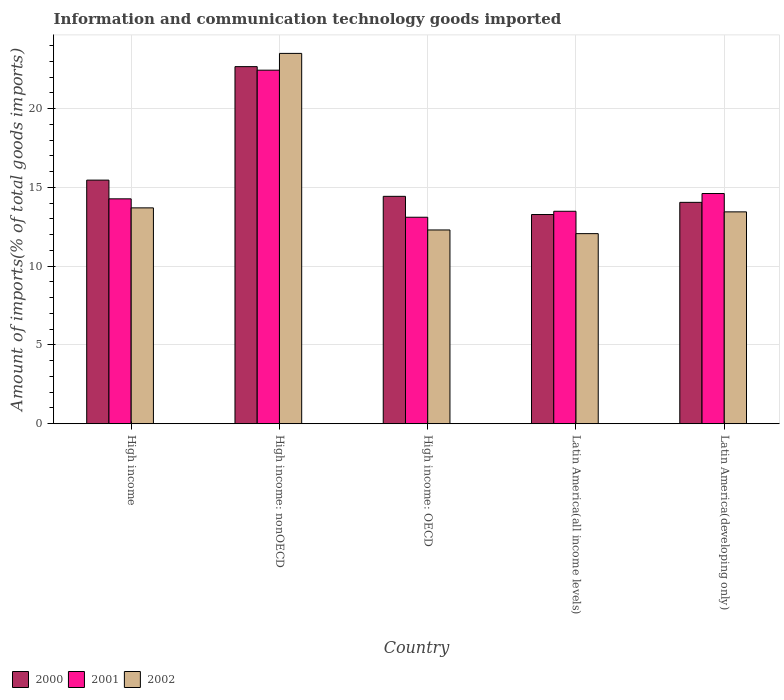How many different coloured bars are there?
Provide a succinct answer. 3. Are the number of bars per tick equal to the number of legend labels?
Make the answer very short. Yes. Are the number of bars on each tick of the X-axis equal?
Provide a short and direct response. Yes. How many bars are there on the 2nd tick from the left?
Provide a short and direct response. 3. What is the label of the 1st group of bars from the left?
Offer a terse response. High income. In how many cases, is the number of bars for a given country not equal to the number of legend labels?
Your answer should be compact. 0. What is the amount of goods imported in 2001 in Latin America(all income levels)?
Offer a very short reply. 13.48. Across all countries, what is the maximum amount of goods imported in 2000?
Offer a very short reply. 22.66. Across all countries, what is the minimum amount of goods imported in 2002?
Provide a short and direct response. 12.06. In which country was the amount of goods imported in 2001 maximum?
Provide a succinct answer. High income: nonOECD. In which country was the amount of goods imported in 2002 minimum?
Offer a very short reply. Latin America(all income levels). What is the total amount of goods imported in 2001 in the graph?
Offer a very short reply. 77.89. What is the difference between the amount of goods imported in 2001 in Latin America(all income levels) and that in Latin America(developing only)?
Your answer should be very brief. -1.13. What is the difference between the amount of goods imported in 2002 in Latin America(developing only) and the amount of goods imported in 2000 in High income: OECD?
Make the answer very short. -0.99. What is the average amount of goods imported in 2002 per country?
Your answer should be very brief. 15. What is the difference between the amount of goods imported of/in 2000 and amount of goods imported of/in 2001 in High income?
Give a very brief answer. 1.19. In how many countries, is the amount of goods imported in 2002 greater than 10 %?
Offer a terse response. 5. What is the ratio of the amount of goods imported in 2000 in High income to that in High income: nonOECD?
Offer a very short reply. 0.68. Is the amount of goods imported in 2001 in High income less than that in High income: nonOECD?
Your response must be concise. Yes. What is the difference between the highest and the second highest amount of goods imported in 2001?
Offer a very short reply. -8.16. What is the difference between the highest and the lowest amount of goods imported in 2000?
Your answer should be very brief. 9.38. In how many countries, is the amount of goods imported in 2000 greater than the average amount of goods imported in 2000 taken over all countries?
Make the answer very short. 1. Are all the bars in the graph horizontal?
Offer a terse response. No. How many countries are there in the graph?
Provide a short and direct response. 5. Are the values on the major ticks of Y-axis written in scientific E-notation?
Keep it short and to the point. No. Does the graph contain any zero values?
Give a very brief answer. No. How are the legend labels stacked?
Provide a succinct answer. Horizontal. What is the title of the graph?
Your answer should be compact. Information and communication technology goods imported. What is the label or title of the Y-axis?
Offer a terse response. Amount of imports(% of total goods imports). What is the Amount of imports(% of total goods imports) of 2000 in High income?
Offer a terse response. 15.46. What is the Amount of imports(% of total goods imports) of 2001 in High income?
Offer a very short reply. 14.27. What is the Amount of imports(% of total goods imports) in 2002 in High income?
Offer a terse response. 13.7. What is the Amount of imports(% of total goods imports) in 2000 in High income: nonOECD?
Your answer should be compact. 22.66. What is the Amount of imports(% of total goods imports) in 2001 in High income: nonOECD?
Offer a very short reply. 22.43. What is the Amount of imports(% of total goods imports) in 2002 in High income: nonOECD?
Offer a very short reply. 23.5. What is the Amount of imports(% of total goods imports) in 2000 in High income: OECD?
Keep it short and to the point. 14.43. What is the Amount of imports(% of total goods imports) of 2001 in High income: OECD?
Keep it short and to the point. 13.1. What is the Amount of imports(% of total goods imports) of 2002 in High income: OECD?
Provide a succinct answer. 12.3. What is the Amount of imports(% of total goods imports) in 2000 in Latin America(all income levels)?
Make the answer very short. 13.27. What is the Amount of imports(% of total goods imports) of 2001 in Latin America(all income levels)?
Ensure brevity in your answer.  13.48. What is the Amount of imports(% of total goods imports) of 2002 in Latin America(all income levels)?
Offer a very short reply. 12.06. What is the Amount of imports(% of total goods imports) of 2000 in Latin America(developing only)?
Ensure brevity in your answer.  14.05. What is the Amount of imports(% of total goods imports) in 2001 in Latin America(developing only)?
Make the answer very short. 14.61. What is the Amount of imports(% of total goods imports) of 2002 in Latin America(developing only)?
Offer a very short reply. 13.44. Across all countries, what is the maximum Amount of imports(% of total goods imports) of 2000?
Provide a succinct answer. 22.66. Across all countries, what is the maximum Amount of imports(% of total goods imports) in 2001?
Your response must be concise. 22.43. Across all countries, what is the maximum Amount of imports(% of total goods imports) of 2002?
Offer a very short reply. 23.5. Across all countries, what is the minimum Amount of imports(% of total goods imports) of 2000?
Your answer should be very brief. 13.27. Across all countries, what is the minimum Amount of imports(% of total goods imports) of 2001?
Your answer should be very brief. 13.1. Across all countries, what is the minimum Amount of imports(% of total goods imports) in 2002?
Make the answer very short. 12.06. What is the total Amount of imports(% of total goods imports) in 2000 in the graph?
Ensure brevity in your answer.  79.87. What is the total Amount of imports(% of total goods imports) in 2001 in the graph?
Provide a short and direct response. 77.89. What is the total Amount of imports(% of total goods imports) of 2002 in the graph?
Your answer should be very brief. 75. What is the difference between the Amount of imports(% of total goods imports) in 2000 in High income and that in High income: nonOECD?
Ensure brevity in your answer.  -7.2. What is the difference between the Amount of imports(% of total goods imports) of 2001 in High income and that in High income: nonOECD?
Offer a very short reply. -8.16. What is the difference between the Amount of imports(% of total goods imports) in 2002 in High income and that in High income: nonOECD?
Give a very brief answer. -9.8. What is the difference between the Amount of imports(% of total goods imports) in 2000 in High income and that in High income: OECD?
Provide a short and direct response. 1.03. What is the difference between the Amount of imports(% of total goods imports) of 2001 in High income and that in High income: OECD?
Offer a terse response. 1.17. What is the difference between the Amount of imports(% of total goods imports) of 2002 in High income and that in High income: OECD?
Provide a short and direct response. 1.4. What is the difference between the Amount of imports(% of total goods imports) in 2000 in High income and that in Latin America(all income levels)?
Keep it short and to the point. 2.18. What is the difference between the Amount of imports(% of total goods imports) of 2001 in High income and that in Latin America(all income levels)?
Ensure brevity in your answer.  0.79. What is the difference between the Amount of imports(% of total goods imports) in 2002 in High income and that in Latin America(all income levels)?
Ensure brevity in your answer.  1.63. What is the difference between the Amount of imports(% of total goods imports) of 2000 in High income and that in Latin America(developing only)?
Provide a short and direct response. 1.41. What is the difference between the Amount of imports(% of total goods imports) of 2001 in High income and that in Latin America(developing only)?
Make the answer very short. -0.34. What is the difference between the Amount of imports(% of total goods imports) in 2002 in High income and that in Latin America(developing only)?
Your answer should be very brief. 0.25. What is the difference between the Amount of imports(% of total goods imports) in 2000 in High income: nonOECD and that in High income: OECD?
Provide a succinct answer. 8.23. What is the difference between the Amount of imports(% of total goods imports) in 2001 in High income: nonOECD and that in High income: OECD?
Give a very brief answer. 9.33. What is the difference between the Amount of imports(% of total goods imports) in 2002 in High income: nonOECD and that in High income: OECD?
Your answer should be very brief. 11.2. What is the difference between the Amount of imports(% of total goods imports) of 2000 in High income: nonOECD and that in Latin America(all income levels)?
Your answer should be very brief. 9.38. What is the difference between the Amount of imports(% of total goods imports) in 2001 in High income: nonOECD and that in Latin America(all income levels)?
Your response must be concise. 8.95. What is the difference between the Amount of imports(% of total goods imports) of 2002 in High income: nonOECD and that in Latin America(all income levels)?
Your answer should be very brief. 11.44. What is the difference between the Amount of imports(% of total goods imports) of 2000 in High income: nonOECD and that in Latin America(developing only)?
Ensure brevity in your answer.  8.61. What is the difference between the Amount of imports(% of total goods imports) in 2001 in High income: nonOECD and that in Latin America(developing only)?
Your response must be concise. 7.83. What is the difference between the Amount of imports(% of total goods imports) of 2002 in High income: nonOECD and that in Latin America(developing only)?
Provide a succinct answer. 10.06. What is the difference between the Amount of imports(% of total goods imports) of 2000 in High income: OECD and that in Latin America(all income levels)?
Make the answer very short. 1.15. What is the difference between the Amount of imports(% of total goods imports) in 2001 in High income: OECD and that in Latin America(all income levels)?
Keep it short and to the point. -0.38. What is the difference between the Amount of imports(% of total goods imports) in 2002 in High income: OECD and that in Latin America(all income levels)?
Your answer should be very brief. 0.23. What is the difference between the Amount of imports(% of total goods imports) of 2000 in High income: OECD and that in Latin America(developing only)?
Offer a very short reply. 0.38. What is the difference between the Amount of imports(% of total goods imports) of 2001 in High income: OECD and that in Latin America(developing only)?
Ensure brevity in your answer.  -1.5. What is the difference between the Amount of imports(% of total goods imports) in 2002 in High income: OECD and that in Latin America(developing only)?
Provide a succinct answer. -1.15. What is the difference between the Amount of imports(% of total goods imports) in 2000 in Latin America(all income levels) and that in Latin America(developing only)?
Provide a succinct answer. -0.77. What is the difference between the Amount of imports(% of total goods imports) of 2001 in Latin America(all income levels) and that in Latin America(developing only)?
Provide a succinct answer. -1.13. What is the difference between the Amount of imports(% of total goods imports) of 2002 in Latin America(all income levels) and that in Latin America(developing only)?
Your answer should be very brief. -1.38. What is the difference between the Amount of imports(% of total goods imports) of 2000 in High income and the Amount of imports(% of total goods imports) of 2001 in High income: nonOECD?
Offer a very short reply. -6.97. What is the difference between the Amount of imports(% of total goods imports) in 2000 in High income and the Amount of imports(% of total goods imports) in 2002 in High income: nonOECD?
Offer a very short reply. -8.04. What is the difference between the Amount of imports(% of total goods imports) of 2001 in High income and the Amount of imports(% of total goods imports) of 2002 in High income: nonOECD?
Provide a short and direct response. -9.23. What is the difference between the Amount of imports(% of total goods imports) of 2000 in High income and the Amount of imports(% of total goods imports) of 2001 in High income: OECD?
Provide a succinct answer. 2.36. What is the difference between the Amount of imports(% of total goods imports) in 2000 in High income and the Amount of imports(% of total goods imports) in 2002 in High income: OECD?
Give a very brief answer. 3.16. What is the difference between the Amount of imports(% of total goods imports) in 2001 in High income and the Amount of imports(% of total goods imports) in 2002 in High income: OECD?
Offer a very short reply. 1.97. What is the difference between the Amount of imports(% of total goods imports) of 2000 in High income and the Amount of imports(% of total goods imports) of 2001 in Latin America(all income levels)?
Make the answer very short. 1.98. What is the difference between the Amount of imports(% of total goods imports) in 2000 in High income and the Amount of imports(% of total goods imports) in 2002 in Latin America(all income levels)?
Your response must be concise. 3.4. What is the difference between the Amount of imports(% of total goods imports) in 2001 in High income and the Amount of imports(% of total goods imports) in 2002 in Latin America(all income levels)?
Offer a very short reply. 2.21. What is the difference between the Amount of imports(% of total goods imports) in 2000 in High income and the Amount of imports(% of total goods imports) in 2001 in Latin America(developing only)?
Keep it short and to the point. 0.85. What is the difference between the Amount of imports(% of total goods imports) of 2000 in High income and the Amount of imports(% of total goods imports) of 2002 in Latin America(developing only)?
Make the answer very short. 2.02. What is the difference between the Amount of imports(% of total goods imports) in 2001 in High income and the Amount of imports(% of total goods imports) in 2002 in Latin America(developing only)?
Offer a very short reply. 0.83. What is the difference between the Amount of imports(% of total goods imports) in 2000 in High income: nonOECD and the Amount of imports(% of total goods imports) in 2001 in High income: OECD?
Your answer should be very brief. 9.56. What is the difference between the Amount of imports(% of total goods imports) in 2000 in High income: nonOECD and the Amount of imports(% of total goods imports) in 2002 in High income: OECD?
Your response must be concise. 10.36. What is the difference between the Amount of imports(% of total goods imports) in 2001 in High income: nonOECD and the Amount of imports(% of total goods imports) in 2002 in High income: OECD?
Offer a terse response. 10.14. What is the difference between the Amount of imports(% of total goods imports) of 2000 in High income: nonOECD and the Amount of imports(% of total goods imports) of 2001 in Latin America(all income levels)?
Make the answer very short. 9.18. What is the difference between the Amount of imports(% of total goods imports) in 2000 in High income: nonOECD and the Amount of imports(% of total goods imports) in 2002 in Latin America(all income levels)?
Ensure brevity in your answer.  10.6. What is the difference between the Amount of imports(% of total goods imports) of 2001 in High income: nonOECD and the Amount of imports(% of total goods imports) of 2002 in Latin America(all income levels)?
Your answer should be very brief. 10.37. What is the difference between the Amount of imports(% of total goods imports) of 2000 in High income: nonOECD and the Amount of imports(% of total goods imports) of 2001 in Latin America(developing only)?
Ensure brevity in your answer.  8.05. What is the difference between the Amount of imports(% of total goods imports) in 2000 in High income: nonOECD and the Amount of imports(% of total goods imports) in 2002 in Latin America(developing only)?
Offer a very short reply. 9.22. What is the difference between the Amount of imports(% of total goods imports) of 2001 in High income: nonOECD and the Amount of imports(% of total goods imports) of 2002 in Latin America(developing only)?
Ensure brevity in your answer.  8.99. What is the difference between the Amount of imports(% of total goods imports) of 2000 in High income: OECD and the Amount of imports(% of total goods imports) of 2001 in Latin America(all income levels)?
Make the answer very short. 0.95. What is the difference between the Amount of imports(% of total goods imports) in 2000 in High income: OECD and the Amount of imports(% of total goods imports) in 2002 in Latin America(all income levels)?
Make the answer very short. 2.37. What is the difference between the Amount of imports(% of total goods imports) in 2001 in High income: OECD and the Amount of imports(% of total goods imports) in 2002 in Latin America(all income levels)?
Your answer should be very brief. 1.04. What is the difference between the Amount of imports(% of total goods imports) of 2000 in High income: OECD and the Amount of imports(% of total goods imports) of 2001 in Latin America(developing only)?
Your answer should be compact. -0.18. What is the difference between the Amount of imports(% of total goods imports) in 2000 in High income: OECD and the Amount of imports(% of total goods imports) in 2002 in Latin America(developing only)?
Your answer should be compact. 0.99. What is the difference between the Amount of imports(% of total goods imports) of 2001 in High income: OECD and the Amount of imports(% of total goods imports) of 2002 in Latin America(developing only)?
Provide a succinct answer. -0.34. What is the difference between the Amount of imports(% of total goods imports) in 2000 in Latin America(all income levels) and the Amount of imports(% of total goods imports) in 2001 in Latin America(developing only)?
Ensure brevity in your answer.  -1.33. What is the difference between the Amount of imports(% of total goods imports) of 2000 in Latin America(all income levels) and the Amount of imports(% of total goods imports) of 2002 in Latin America(developing only)?
Provide a short and direct response. -0.17. What is the difference between the Amount of imports(% of total goods imports) of 2001 in Latin America(all income levels) and the Amount of imports(% of total goods imports) of 2002 in Latin America(developing only)?
Offer a terse response. 0.04. What is the average Amount of imports(% of total goods imports) in 2000 per country?
Provide a succinct answer. 15.97. What is the average Amount of imports(% of total goods imports) of 2001 per country?
Give a very brief answer. 15.58. What is the average Amount of imports(% of total goods imports) in 2002 per country?
Make the answer very short. 15. What is the difference between the Amount of imports(% of total goods imports) of 2000 and Amount of imports(% of total goods imports) of 2001 in High income?
Your response must be concise. 1.19. What is the difference between the Amount of imports(% of total goods imports) in 2000 and Amount of imports(% of total goods imports) in 2002 in High income?
Provide a short and direct response. 1.76. What is the difference between the Amount of imports(% of total goods imports) of 2001 and Amount of imports(% of total goods imports) of 2002 in High income?
Offer a terse response. 0.57. What is the difference between the Amount of imports(% of total goods imports) of 2000 and Amount of imports(% of total goods imports) of 2001 in High income: nonOECD?
Provide a succinct answer. 0.23. What is the difference between the Amount of imports(% of total goods imports) of 2000 and Amount of imports(% of total goods imports) of 2002 in High income: nonOECD?
Provide a succinct answer. -0.84. What is the difference between the Amount of imports(% of total goods imports) of 2001 and Amount of imports(% of total goods imports) of 2002 in High income: nonOECD?
Your answer should be very brief. -1.07. What is the difference between the Amount of imports(% of total goods imports) of 2000 and Amount of imports(% of total goods imports) of 2001 in High income: OECD?
Provide a short and direct response. 1.33. What is the difference between the Amount of imports(% of total goods imports) of 2000 and Amount of imports(% of total goods imports) of 2002 in High income: OECD?
Offer a terse response. 2.13. What is the difference between the Amount of imports(% of total goods imports) of 2001 and Amount of imports(% of total goods imports) of 2002 in High income: OECD?
Offer a terse response. 0.81. What is the difference between the Amount of imports(% of total goods imports) of 2000 and Amount of imports(% of total goods imports) of 2001 in Latin America(all income levels)?
Provide a succinct answer. -0.21. What is the difference between the Amount of imports(% of total goods imports) in 2000 and Amount of imports(% of total goods imports) in 2002 in Latin America(all income levels)?
Give a very brief answer. 1.21. What is the difference between the Amount of imports(% of total goods imports) of 2001 and Amount of imports(% of total goods imports) of 2002 in Latin America(all income levels)?
Offer a very short reply. 1.42. What is the difference between the Amount of imports(% of total goods imports) of 2000 and Amount of imports(% of total goods imports) of 2001 in Latin America(developing only)?
Provide a short and direct response. -0.56. What is the difference between the Amount of imports(% of total goods imports) of 2000 and Amount of imports(% of total goods imports) of 2002 in Latin America(developing only)?
Your answer should be compact. 0.6. What is the difference between the Amount of imports(% of total goods imports) of 2001 and Amount of imports(% of total goods imports) of 2002 in Latin America(developing only)?
Your answer should be compact. 1.16. What is the ratio of the Amount of imports(% of total goods imports) in 2000 in High income to that in High income: nonOECD?
Give a very brief answer. 0.68. What is the ratio of the Amount of imports(% of total goods imports) of 2001 in High income to that in High income: nonOECD?
Ensure brevity in your answer.  0.64. What is the ratio of the Amount of imports(% of total goods imports) in 2002 in High income to that in High income: nonOECD?
Your answer should be compact. 0.58. What is the ratio of the Amount of imports(% of total goods imports) of 2000 in High income to that in High income: OECD?
Offer a terse response. 1.07. What is the ratio of the Amount of imports(% of total goods imports) in 2001 in High income to that in High income: OECD?
Provide a succinct answer. 1.09. What is the ratio of the Amount of imports(% of total goods imports) in 2002 in High income to that in High income: OECD?
Provide a short and direct response. 1.11. What is the ratio of the Amount of imports(% of total goods imports) of 2000 in High income to that in Latin America(all income levels)?
Your answer should be very brief. 1.16. What is the ratio of the Amount of imports(% of total goods imports) in 2001 in High income to that in Latin America(all income levels)?
Make the answer very short. 1.06. What is the ratio of the Amount of imports(% of total goods imports) in 2002 in High income to that in Latin America(all income levels)?
Your answer should be very brief. 1.14. What is the ratio of the Amount of imports(% of total goods imports) in 2000 in High income to that in Latin America(developing only)?
Your response must be concise. 1.1. What is the ratio of the Amount of imports(% of total goods imports) in 2001 in High income to that in Latin America(developing only)?
Give a very brief answer. 0.98. What is the ratio of the Amount of imports(% of total goods imports) of 2002 in High income to that in Latin America(developing only)?
Your answer should be very brief. 1.02. What is the ratio of the Amount of imports(% of total goods imports) in 2000 in High income: nonOECD to that in High income: OECD?
Your answer should be compact. 1.57. What is the ratio of the Amount of imports(% of total goods imports) of 2001 in High income: nonOECD to that in High income: OECD?
Make the answer very short. 1.71. What is the ratio of the Amount of imports(% of total goods imports) in 2002 in High income: nonOECD to that in High income: OECD?
Your answer should be very brief. 1.91. What is the ratio of the Amount of imports(% of total goods imports) in 2000 in High income: nonOECD to that in Latin America(all income levels)?
Provide a short and direct response. 1.71. What is the ratio of the Amount of imports(% of total goods imports) in 2001 in High income: nonOECD to that in Latin America(all income levels)?
Offer a very short reply. 1.66. What is the ratio of the Amount of imports(% of total goods imports) of 2002 in High income: nonOECD to that in Latin America(all income levels)?
Offer a very short reply. 1.95. What is the ratio of the Amount of imports(% of total goods imports) in 2000 in High income: nonOECD to that in Latin America(developing only)?
Offer a very short reply. 1.61. What is the ratio of the Amount of imports(% of total goods imports) in 2001 in High income: nonOECD to that in Latin America(developing only)?
Make the answer very short. 1.54. What is the ratio of the Amount of imports(% of total goods imports) in 2002 in High income: nonOECD to that in Latin America(developing only)?
Your answer should be very brief. 1.75. What is the ratio of the Amount of imports(% of total goods imports) in 2000 in High income: OECD to that in Latin America(all income levels)?
Keep it short and to the point. 1.09. What is the ratio of the Amount of imports(% of total goods imports) in 2001 in High income: OECD to that in Latin America(all income levels)?
Your answer should be compact. 0.97. What is the ratio of the Amount of imports(% of total goods imports) in 2002 in High income: OECD to that in Latin America(all income levels)?
Your answer should be compact. 1.02. What is the ratio of the Amount of imports(% of total goods imports) in 2000 in High income: OECD to that in Latin America(developing only)?
Offer a terse response. 1.03. What is the ratio of the Amount of imports(% of total goods imports) in 2001 in High income: OECD to that in Latin America(developing only)?
Provide a succinct answer. 0.9. What is the ratio of the Amount of imports(% of total goods imports) in 2002 in High income: OECD to that in Latin America(developing only)?
Your answer should be compact. 0.91. What is the ratio of the Amount of imports(% of total goods imports) of 2000 in Latin America(all income levels) to that in Latin America(developing only)?
Your answer should be very brief. 0.95. What is the ratio of the Amount of imports(% of total goods imports) of 2001 in Latin America(all income levels) to that in Latin America(developing only)?
Offer a very short reply. 0.92. What is the ratio of the Amount of imports(% of total goods imports) of 2002 in Latin America(all income levels) to that in Latin America(developing only)?
Give a very brief answer. 0.9. What is the difference between the highest and the second highest Amount of imports(% of total goods imports) in 2000?
Your answer should be very brief. 7.2. What is the difference between the highest and the second highest Amount of imports(% of total goods imports) in 2001?
Your answer should be very brief. 7.83. What is the difference between the highest and the second highest Amount of imports(% of total goods imports) of 2002?
Offer a terse response. 9.8. What is the difference between the highest and the lowest Amount of imports(% of total goods imports) of 2000?
Your answer should be very brief. 9.38. What is the difference between the highest and the lowest Amount of imports(% of total goods imports) in 2001?
Your answer should be very brief. 9.33. What is the difference between the highest and the lowest Amount of imports(% of total goods imports) in 2002?
Offer a very short reply. 11.44. 